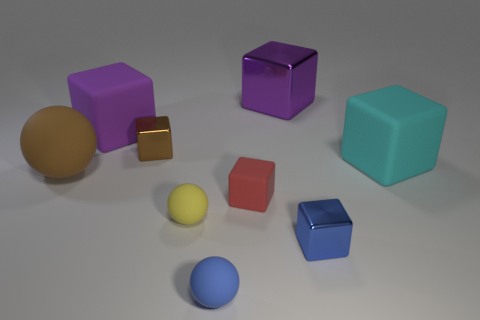What material is the other object that is the same color as the big metallic thing?
Your response must be concise. Rubber. Does the big ball have the same color as the small metal cube on the left side of the red matte block?
Provide a short and direct response. Yes. What is the brown cube made of?
Your answer should be very brief. Metal. Does the yellow object have the same material as the cyan thing?
Offer a terse response. Yes. What is the size of the cyan object that is the same shape as the brown metal object?
Offer a very short reply. Large. What is the material of the block that is both to the right of the big purple metallic block and in front of the cyan rubber block?
Keep it short and to the point. Metal. Do the small thing behind the brown ball and the big rubber sphere have the same color?
Keep it short and to the point. Yes. There is a red thing that is to the right of the brown shiny object; what size is it?
Ensure brevity in your answer.  Small. What shape is the matte thing that is right of the blue thing that is right of the large shiny cube?
Your answer should be compact. Cube. There is a big object that is the same shape as the small yellow matte thing; what color is it?
Give a very brief answer. Brown. 